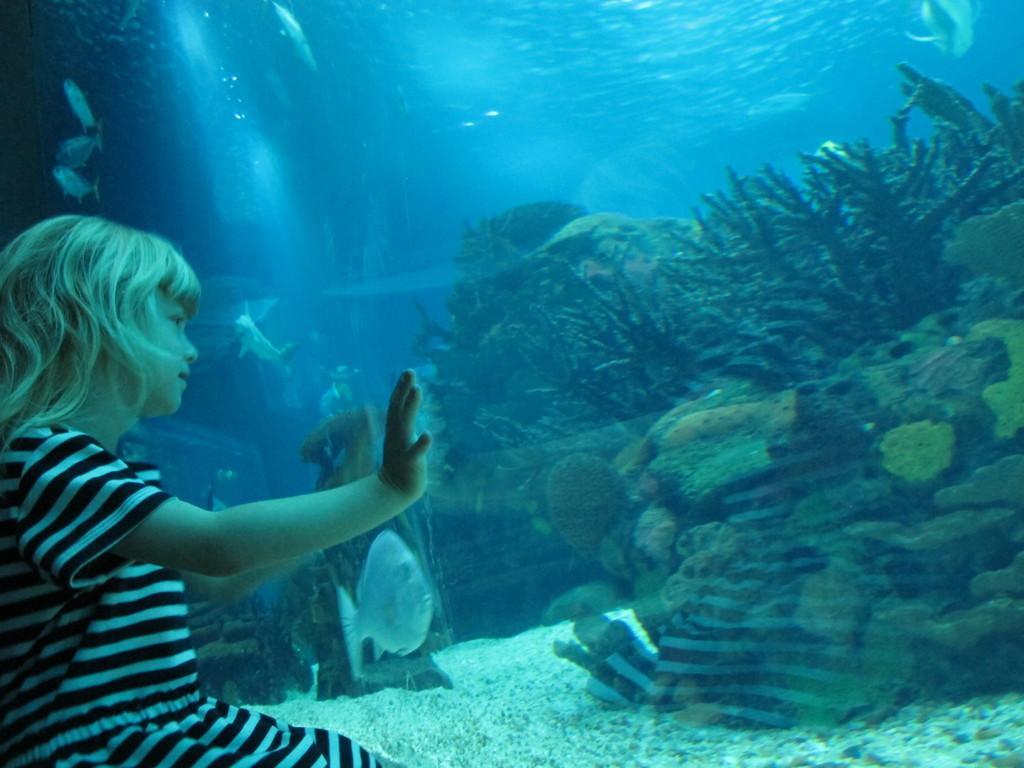In one or two sentences, can you explain what this image depicts? On the left side of the image there is a girl, before her we can see an aquarium and there are fishes in the aquarium. We can see water plants. 